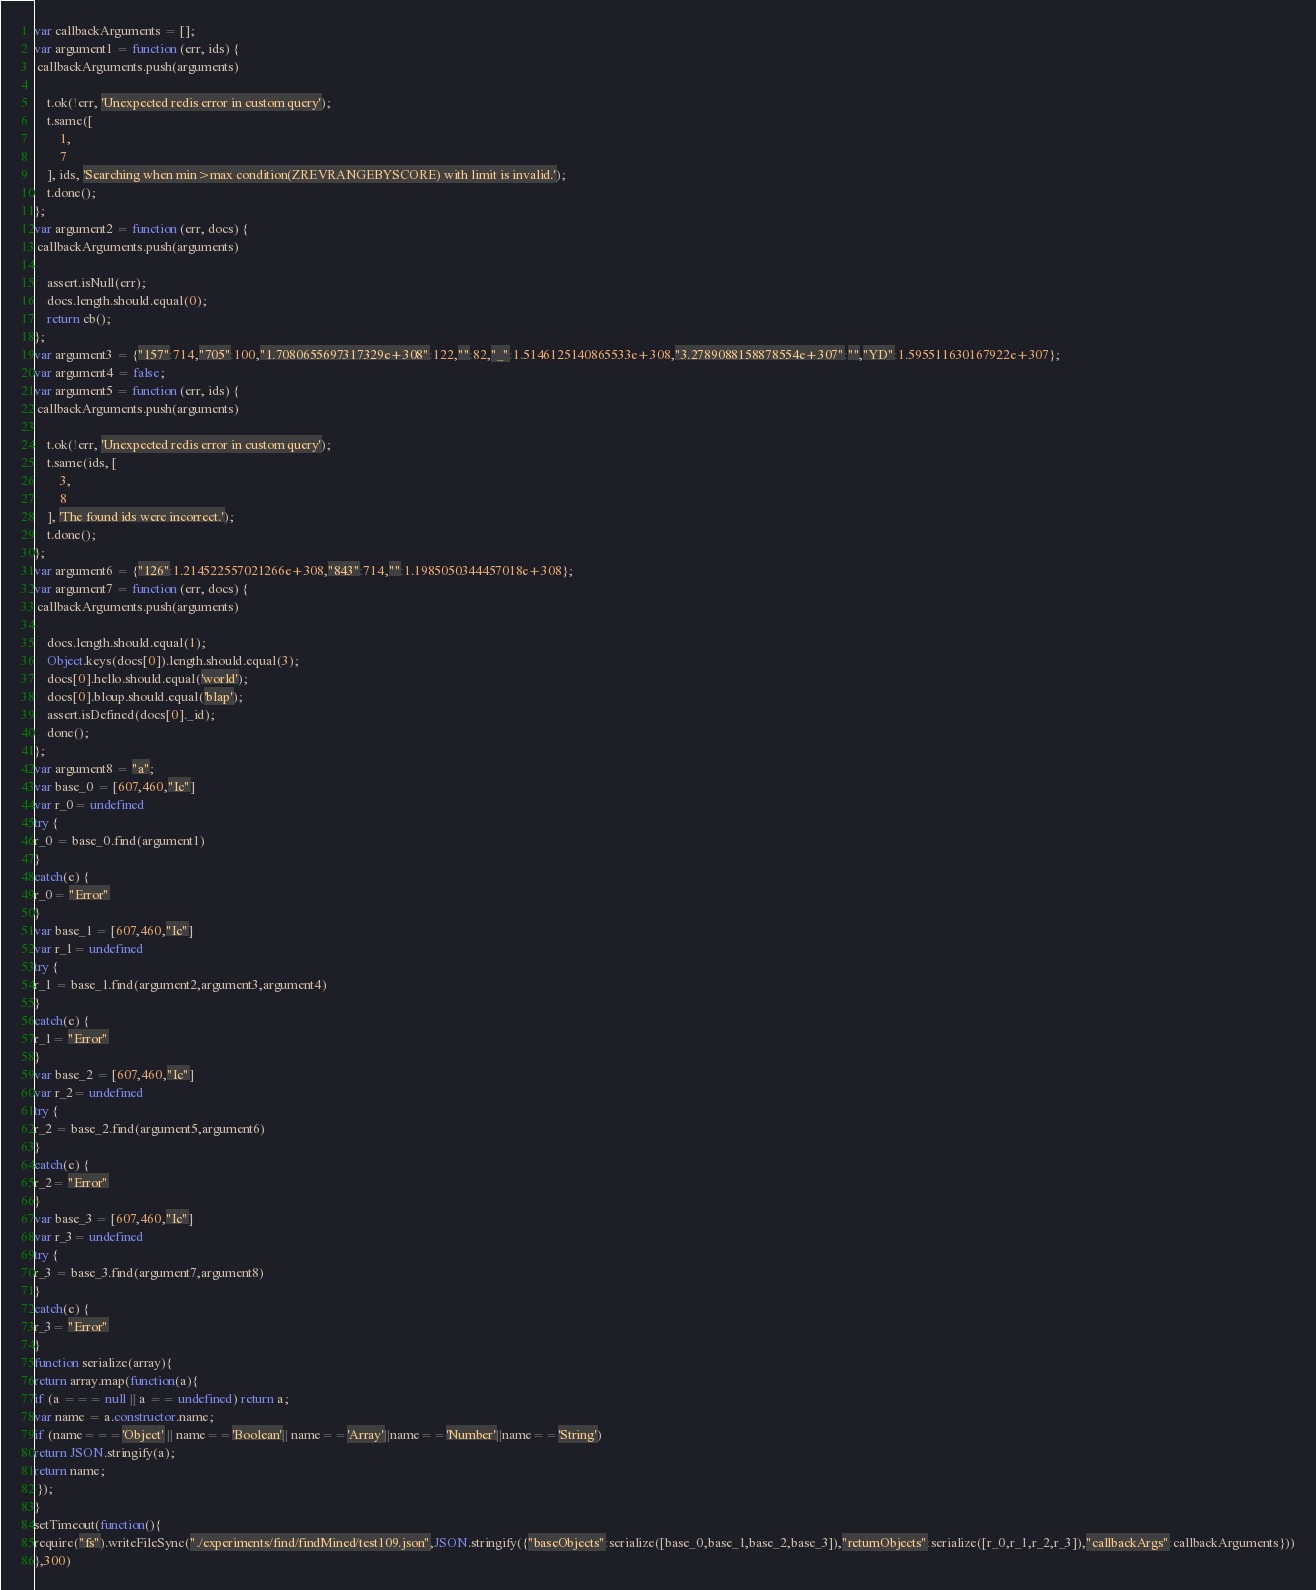<code> <loc_0><loc_0><loc_500><loc_500><_JavaScript_>





var callbackArguments = [];
var argument1 = function (err, ids) {
 callbackArguments.push(arguments) 

    t.ok(!err, 'Unexpected redis error in custom query');
    t.same([
        1,
        7
    ], ids, 'Searching when min>max condition(ZREVRANGEBYSCORE) with limit is invalid.');
    t.done();
};
var argument2 = function (err, docs) {
 callbackArguments.push(arguments) 

    assert.isNull(err);
    docs.length.should.equal(0);
    return cb();
};
var argument3 = {"157":714,"705":100,"1.7080655697317329e+308":122,"":82,"_":1.5146125140865533e+308,"3.2789088158878554e+307":"","YD":1.595511630167922e+307};
var argument4 = false;
var argument5 = function (err, ids) {
 callbackArguments.push(arguments) 

    t.ok(!err, 'Unexpected redis error in custom query');
    t.same(ids, [
        3,
        8
    ], 'The found ids were incorrect.');
    t.done();
};
var argument6 = {"126":1.214522557021266e+308,"843":714,"":1.1985050344457018e+308};
var argument7 = function (err, docs) {
 callbackArguments.push(arguments) 

    docs.length.should.equal(1);
    Object.keys(docs[0]).length.should.equal(3);
    docs[0].hello.should.equal('world');
    docs[0].bloup.should.equal('blap');
    assert.isDefined(docs[0]._id);
    done();
};
var argument8 = "a";
var base_0 = [607,460,"Ic"]
var r_0= undefined
try {
r_0 = base_0.find(argument1)
}
catch(e) {
r_0= "Error"
}
var base_1 = [607,460,"Ic"]
var r_1= undefined
try {
r_1 = base_1.find(argument2,argument3,argument4)
}
catch(e) {
r_1= "Error"
}
var base_2 = [607,460,"Ic"]
var r_2= undefined
try {
r_2 = base_2.find(argument5,argument6)
}
catch(e) {
r_2= "Error"
}
var base_3 = [607,460,"Ic"]
var r_3= undefined
try {
r_3 = base_3.find(argument7,argument8)
}
catch(e) {
r_3= "Error"
}
function serialize(array){
return array.map(function(a){
if (a === null || a == undefined) return a;
var name = a.constructor.name;
if (name==='Object' || name=='Boolean'|| name=='Array'||name=='Number'||name=='String')
return JSON.stringify(a);
return name;
 });
}
setTimeout(function(){
require("fs").writeFileSync("./experiments/find/findMined/test109.json",JSON.stringify({"baseObjects":serialize([base_0,base_1,base_2,base_3]),"returnObjects":serialize([r_0,r_1,r_2,r_3]),"callbackArgs":callbackArguments}))
},300)</code> 